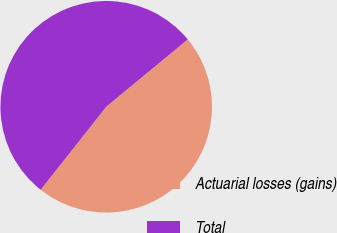Convert chart. <chart><loc_0><loc_0><loc_500><loc_500><pie_chart><fcel>Actuarial losses (gains)<fcel>Total<nl><fcel>46.62%<fcel>53.38%<nl></chart> 